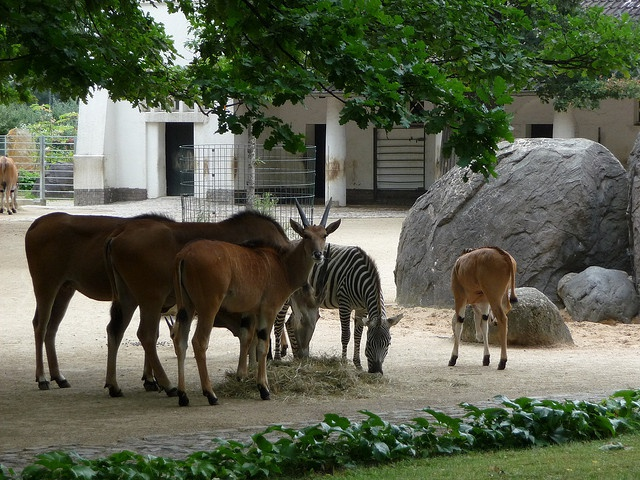Describe the objects in this image and their specific colors. I can see a zebra in black, gray, and lightgray tones in this image. 